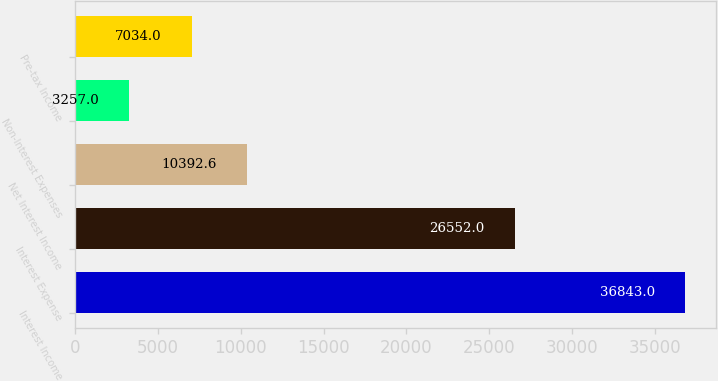Convert chart to OTSL. <chart><loc_0><loc_0><loc_500><loc_500><bar_chart><fcel>Interest Income<fcel>Interest Expense<fcel>Net Interest Income<fcel>Non-Interest Expenses<fcel>Pre-tax Income<nl><fcel>36843<fcel>26552<fcel>10392.6<fcel>3257<fcel>7034<nl></chart> 